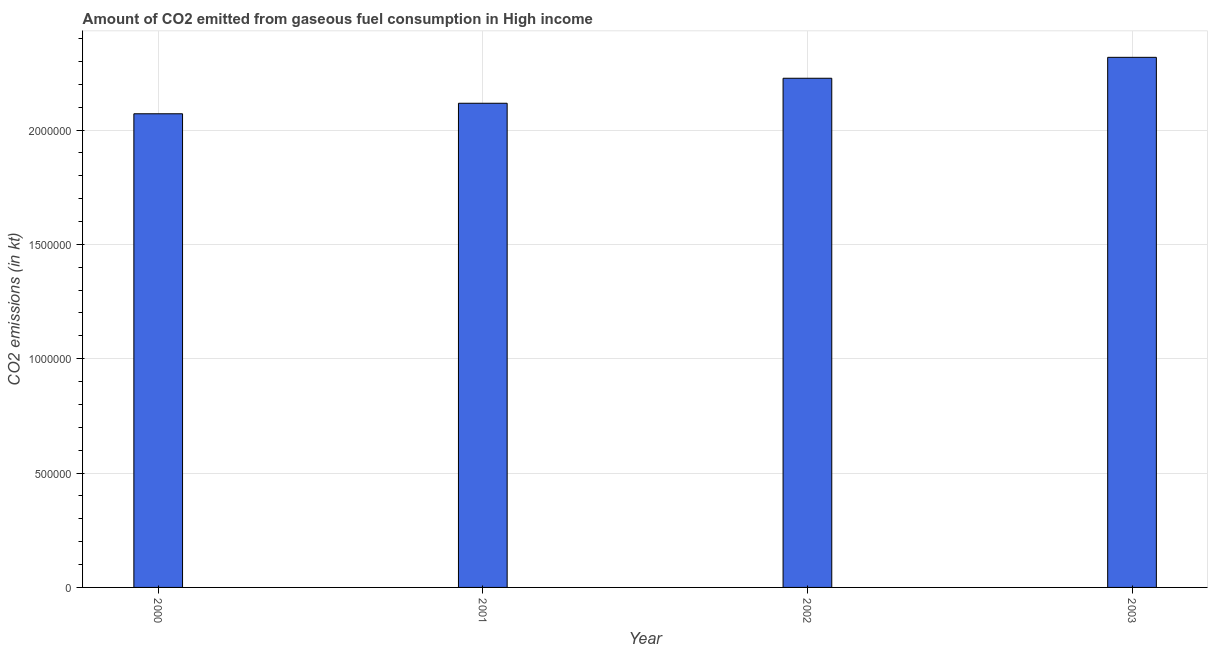Does the graph contain any zero values?
Make the answer very short. No. Does the graph contain grids?
Provide a short and direct response. Yes. What is the title of the graph?
Your answer should be compact. Amount of CO2 emitted from gaseous fuel consumption in High income. What is the label or title of the Y-axis?
Your answer should be very brief. CO2 emissions (in kt). What is the co2 emissions from gaseous fuel consumption in 2002?
Ensure brevity in your answer.  2.23e+06. Across all years, what is the maximum co2 emissions from gaseous fuel consumption?
Make the answer very short. 2.32e+06. Across all years, what is the minimum co2 emissions from gaseous fuel consumption?
Your response must be concise. 2.07e+06. In which year was the co2 emissions from gaseous fuel consumption minimum?
Provide a succinct answer. 2000. What is the sum of the co2 emissions from gaseous fuel consumption?
Provide a succinct answer. 8.73e+06. What is the difference between the co2 emissions from gaseous fuel consumption in 2002 and 2003?
Keep it short and to the point. -9.15e+04. What is the average co2 emissions from gaseous fuel consumption per year?
Make the answer very short. 2.18e+06. What is the median co2 emissions from gaseous fuel consumption?
Ensure brevity in your answer.  2.17e+06. In how many years, is the co2 emissions from gaseous fuel consumption greater than 1500000 kt?
Provide a short and direct response. 4. What is the ratio of the co2 emissions from gaseous fuel consumption in 2001 to that in 2002?
Your answer should be compact. 0.95. Is the co2 emissions from gaseous fuel consumption in 2000 less than that in 2002?
Provide a short and direct response. Yes. What is the difference between the highest and the second highest co2 emissions from gaseous fuel consumption?
Ensure brevity in your answer.  9.15e+04. Is the sum of the co2 emissions from gaseous fuel consumption in 2000 and 2002 greater than the maximum co2 emissions from gaseous fuel consumption across all years?
Provide a short and direct response. Yes. What is the difference between the highest and the lowest co2 emissions from gaseous fuel consumption?
Your answer should be very brief. 2.47e+05. How many years are there in the graph?
Make the answer very short. 4. What is the CO2 emissions (in kt) in 2000?
Your response must be concise. 2.07e+06. What is the CO2 emissions (in kt) of 2001?
Your answer should be compact. 2.12e+06. What is the CO2 emissions (in kt) of 2002?
Your answer should be very brief. 2.23e+06. What is the CO2 emissions (in kt) of 2003?
Give a very brief answer. 2.32e+06. What is the difference between the CO2 emissions (in kt) in 2000 and 2001?
Give a very brief answer. -4.60e+04. What is the difference between the CO2 emissions (in kt) in 2000 and 2002?
Provide a short and direct response. -1.55e+05. What is the difference between the CO2 emissions (in kt) in 2000 and 2003?
Give a very brief answer. -2.47e+05. What is the difference between the CO2 emissions (in kt) in 2001 and 2002?
Offer a very short reply. -1.09e+05. What is the difference between the CO2 emissions (in kt) in 2001 and 2003?
Your answer should be compact. -2.01e+05. What is the difference between the CO2 emissions (in kt) in 2002 and 2003?
Ensure brevity in your answer.  -9.15e+04. What is the ratio of the CO2 emissions (in kt) in 2000 to that in 2002?
Your answer should be very brief. 0.93. What is the ratio of the CO2 emissions (in kt) in 2000 to that in 2003?
Provide a succinct answer. 0.89. What is the ratio of the CO2 emissions (in kt) in 2001 to that in 2002?
Your response must be concise. 0.95. 